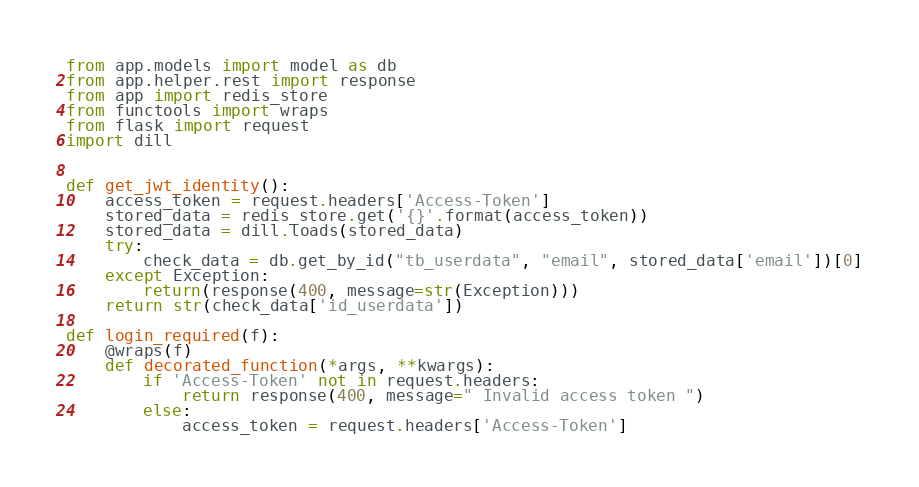Convert code to text. <code><loc_0><loc_0><loc_500><loc_500><_Python_>from app.models import model as db
from app.helper.rest import response
from app import redis_store
from functools import wraps
from flask import request
import dill


def get_jwt_identity():
    access_token = request.headers['Access-Token']
    stored_data = redis_store.get('{}'.format(access_token))
    stored_data = dill.loads(stored_data)
    try:
        check_data = db.get_by_id("tb_userdata", "email", stored_data['email'])[0]
    except Exception:
        return(response(400, message=str(Exception)))
    return str(check_data['id_userdata'])

def login_required(f):
    @wraps(f)
    def decorated_function(*args, **kwargs):
        if 'Access-Token' not in request.headers:
            return response(400, message=" Invalid access token ")
        else:
            access_token = request.headers['Access-Token']</code> 